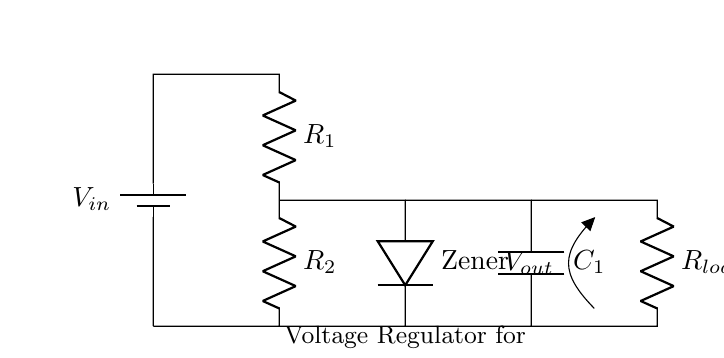What is the input voltage of the circuit? The input voltage is represented as \( V_{in} \), which is indicated by the battery symbol at the top of the circuit.
Answer: V_{in} What is the function of the Zener diode in this circuit? The Zener diode is used for voltage regulation, maintaining a constant output voltage across the load despite changes in input voltage or load conditions.
Answer: Voltage regulation How many resistors are in the circuit? There are two resistors, labeled \( R_1 \) and \( R_2 \), shown connected in series.
Answer: 2 What is the output voltage indicated as? The output voltage is indicated as \( V_{out} \), which is shown at the junction before the load resistor \( R_{load} \).
Answer: V_{out} How is the load resistor connected in this circuit? The load resistor \( R_{load} \) is connected in parallel with the capacitor \( C_1 \) and in series with the output voltage point, allowing it to receive regulated voltage.
Answer: In parallel What effect will increasing \( R_1 \) have on \( V_{out} \)? Increasing \( R_1 \) will increase the voltage drop across \( R_1 \), thereby reducing \( V_{out} \) as it changes the division of voltage in the voltage divider formed by \( R_1 \) and \( R_2 \).
Answer: Decrease \( V_{out} \) What is the role of the capacitor in this circuit? The capacitor \( C_1 \) helps stabilize the voltage output by smoothing out fluctuations, ensuring a more constant voltage across the load.
Answer: Voltage stabilization 